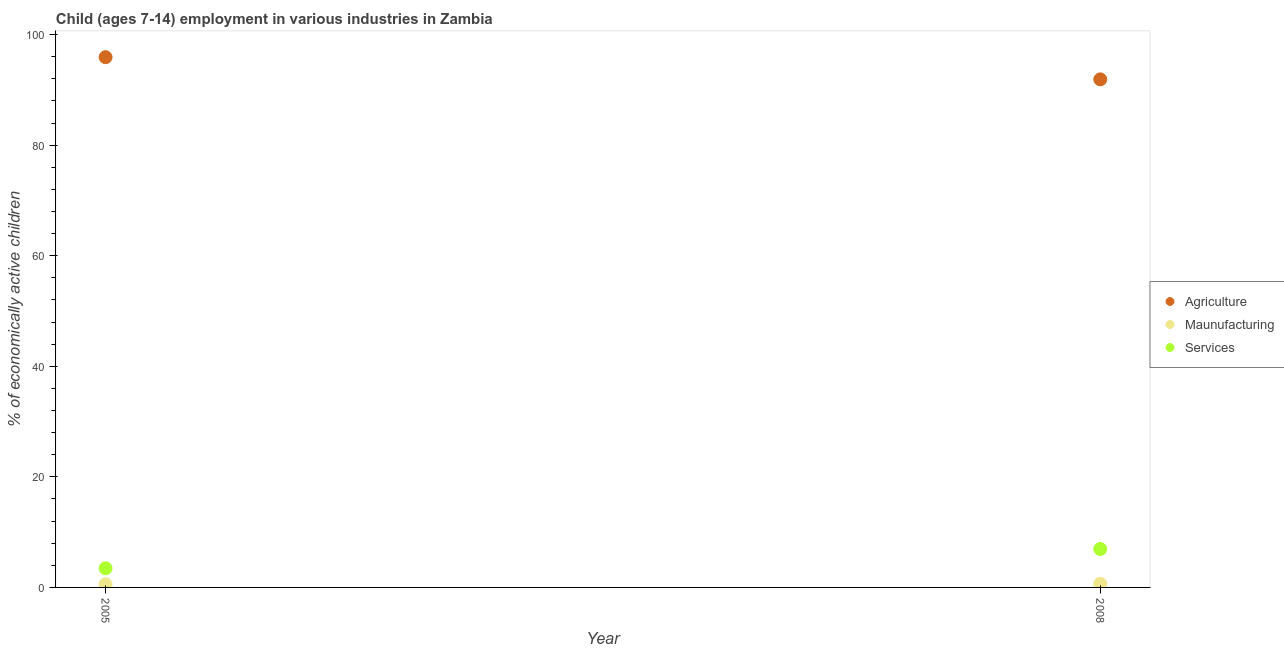Is the number of dotlines equal to the number of legend labels?
Your response must be concise. Yes. What is the percentage of economically active children in agriculture in 2005?
Your answer should be very brief. 95.91. Across all years, what is the maximum percentage of economically active children in agriculture?
Offer a very short reply. 95.91. Across all years, what is the minimum percentage of economically active children in services?
Keep it short and to the point. 3.47. What is the total percentage of economically active children in services in the graph?
Your answer should be very brief. 10.42. What is the difference between the percentage of economically active children in agriculture in 2005 and that in 2008?
Ensure brevity in your answer.  4.01. What is the difference between the percentage of economically active children in services in 2008 and the percentage of economically active children in manufacturing in 2005?
Give a very brief answer. 6.38. What is the average percentage of economically active children in agriculture per year?
Your response must be concise. 93.91. What is the ratio of the percentage of economically active children in manufacturing in 2005 to that in 2008?
Your answer should be very brief. 0.88. Is the percentage of economically active children in services in 2005 less than that in 2008?
Keep it short and to the point. Yes. Is it the case that in every year, the sum of the percentage of economically active children in agriculture and percentage of economically active children in manufacturing is greater than the percentage of economically active children in services?
Offer a very short reply. Yes. Is the percentage of economically active children in services strictly greater than the percentage of economically active children in manufacturing over the years?
Make the answer very short. Yes. Is the percentage of economically active children in agriculture strictly less than the percentage of economically active children in manufacturing over the years?
Provide a short and direct response. No. How many years are there in the graph?
Keep it short and to the point. 2. Are the values on the major ticks of Y-axis written in scientific E-notation?
Your answer should be very brief. No. Does the graph contain grids?
Give a very brief answer. No. Where does the legend appear in the graph?
Ensure brevity in your answer.  Center right. How many legend labels are there?
Your answer should be very brief. 3. What is the title of the graph?
Provide a succinct answer. Child (ages 7-14) employment in various industries in Zambia. What is the label or title of the Y-axis?
Provide a short and direct response. % of economically active children. What is the % of economically active children in Agriculture in 2005?
Make the answer very short. 95.91. What is the % of economically active children of Maunufacturing in 2005?
Make the answer very short. 0.57. What is the % of economically active children of Services in 2005?
Provide a succinct answer. 3.47. What is the % of economically active children of Agriculture in 2008?
Your answer should be compact. 91.9. What is the % of economically active children of Maunufacturing in 2008?
Give a very brief answer. 0.65. What is the % of economically active children in Services in 2008?
Provide a short and direct response. 6.95. Across all years, what is the maximum % of economically active children of Agriculture?
Offer a terse response. 95.91. Across all years, what is the maximum % of economically active children in Maunufacturing?
Your answer should be very brief. 0.65. Across all years, what is the maximum % of economically active children in Services?
Your response must be concise. 6.95. Across all years, what is the minimum % of economically active children in Agriculture?
Give a very brief answer. 91.9. Across all years, what is the minimum % of economically active children in Maunufacturing?
Provide a short and direct response. 0.57. Across all years, what is the minimum % of economically active children in Services?
Provide a short and direct response. 3.47. What is the total % of economically active children of Agriculture in the graph?
Keep it short and to the point. 187.81. What is the total % of economically active children of Maunufacturing in the graph?
Provide a succinct answer. 1.22. What is the total % of economically active children of Services in the graph?
Offer a very short reply. 10.42. What is the difference between the % of economically active children of Agriculture in 2005 and that in 2008?
Your answer should be very brief. 4.01. What is the difference between the % of economically active children of Maunufacturing in 2005 and that in 2008?
Ensure brevity in your answer.  -0.08. What is the difference between the % of economically active children in Services in 2005 and that in 2008?
Give a very brief answer. -3.48. What is the difference between the % of economically active children in Agriculture in 2005 and the % of economically active children in Maunufacturing in 2008?
Your answer should be very brief. 95.26. What is the difference between the % of economically active children of Agriculture in 2005 and the % of economically active children of Services in 2008?
Provide a short and direct response. 88.96. What is the difference between the % of economically active children in Maunufacturing in 2005 and the % of economically active children in Services in 2008?
Ensure brevity in your answer.  -6.38. What is the average % of economically active children in Agriculture per year?
Your answer should be compact. 93.91. What is the average % of economically active children in Maunufacturing per year?
Your response must be concise. 0.61. What is the average % of economically active children of Services per year?
Ensure brevity in your answer.  5.21. In the year 2005, what is the difference between the % of economically active children of Agriculture and % of economically active children of Maunufacturing?
Make the answer very short. 95.34. In the year 2005, what is the difference between the % of economically active children of Agriculture and % of economically active children of Services?
Offer a terse response. 92.44. In the year 2005, what is the difference between the % of economically active children of Maunufacturing and % of economically active children of Services?
Offer a very short reply. -2.9. In the year 2008, what is the difference between the % of economically active children in Agriculture and % of economically active children in Maunufacturing?
Your response must be concise. 91.25. In the year 2008, what is the difference between the % of economically active children in Agriculture and % of economically active children in Services?
Make the answer very short. 84.95. What is the ratio of the % of economically active children in Agriculture in 2005 to that in 2008?
Your response must be concise. 1.04. What is the ratio of the % of economically active children in Maunufacturing in 2005 to that in 2008?
Your answer should be very brief. 0.88. What is the ratio of the % of economically active children of Services in 2005 to that in 2008?
Provide a short and direct response. 0.5. What is the difference between the highest and the second highest % of economically active children of Agriculture?
Provide a short and direct response. 4.01. What is the difference between the highest and the second highest % of economically active children in Services?
Your response must be concise. 3.48. What is the difference between the highest and the lowest % of economically active children of Agriculture?
Make the answer very short. 4.01. What is the difference between the highest and the lowest % of economically active children of Maunufacturing?
Offer a very short reply. 0.08. What is the difference between the highest and the lowest % of economically active children of Services?
Ensure brevity in your answer.  3.48. 